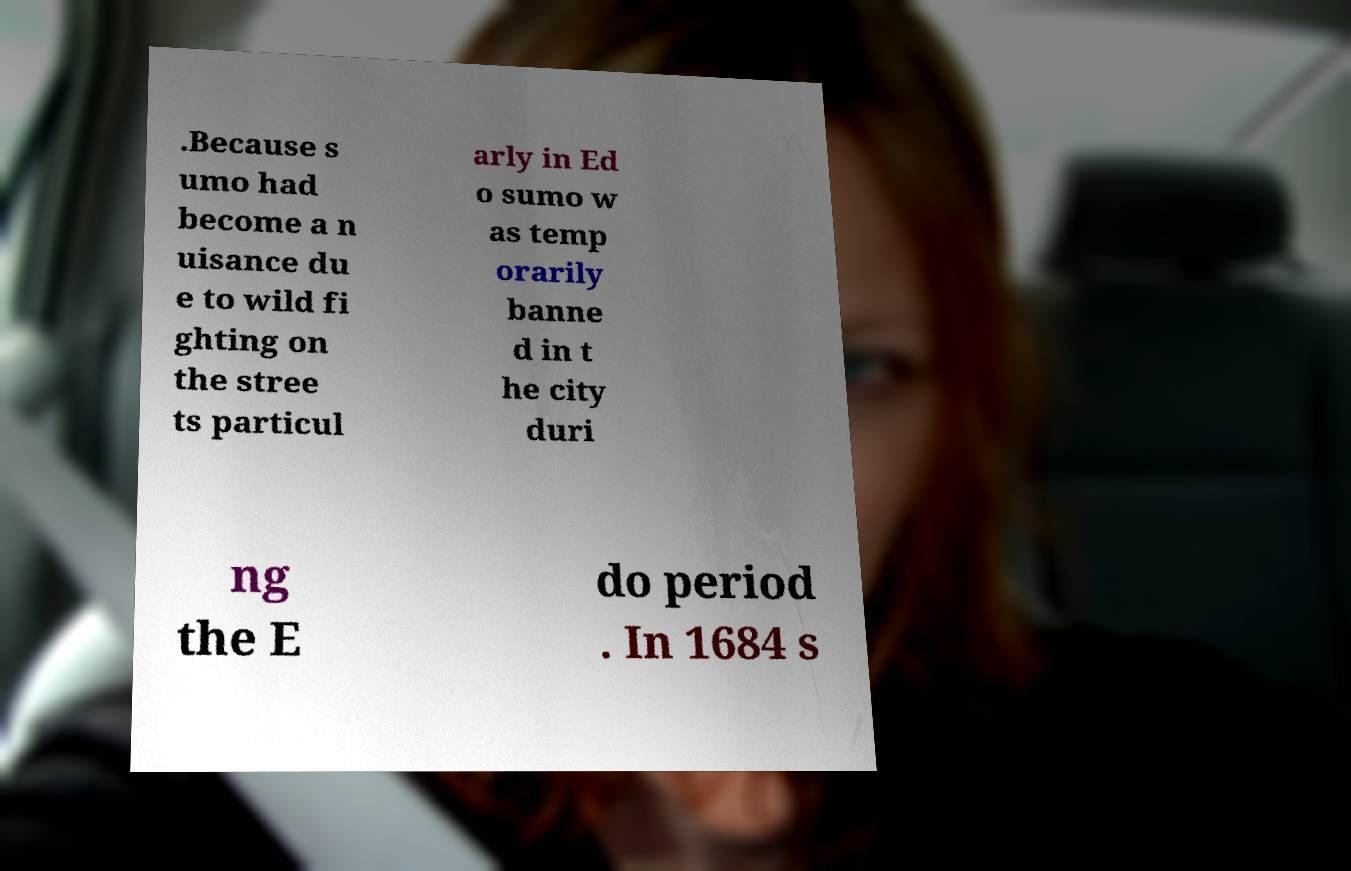Please read and relay the text visible in this image. What does it say? .Because s umo had become a n uisance du e to wild fi ghting on the stree ts particul arly in Ed o sumo w as temp orarily banne d in t he city duri ng the E do period . In 1684 s 